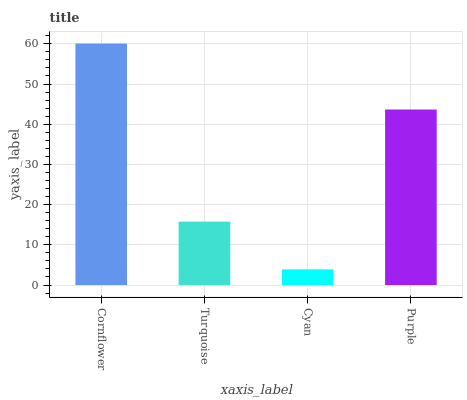Is Cyan the minimum?
Answer yes or no. Yes. Is Cornflower the maximum?
Answer yes or no. Yes. Is Turquoise the minimum?
Answer yes or no. No. Is Turquoise the maximum?
Answer yes or no. No. Is Cornflower greater than Turquoise?
Answer yes or no. Yes. Is Turquoise less than Cornflower?
Answer yes or no. Yes. Is Turquoise greater than Cornflower?
Answer yes or no. No. Is Cornflower less than Turquoise?
Answer yes or no. No. Is Purple the high median?
Answer yes or no. Yes. Is Turquoise the low median?
Answer yes or no. Yes. Is Cyan the high median?
Answer yes or no. No. Is Purple the low median?
Answer yes or no. No. 